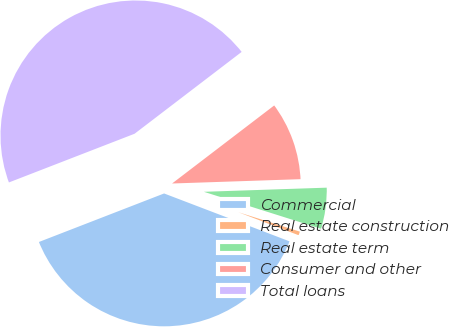Convert chart to OTSL. <chart><loc_0><loc_0><loc_500><loc_500><pie_chart><fcel>Commercial<fcel>Real estate construction<fcel>Real estate term<fcel>Consumer and other<fcel>Total loans<nl><fcel>38.31%<fcel>0.94%<fcel>5.4%<fcel>9.85%<fcel>45.5%<nl></chart> 